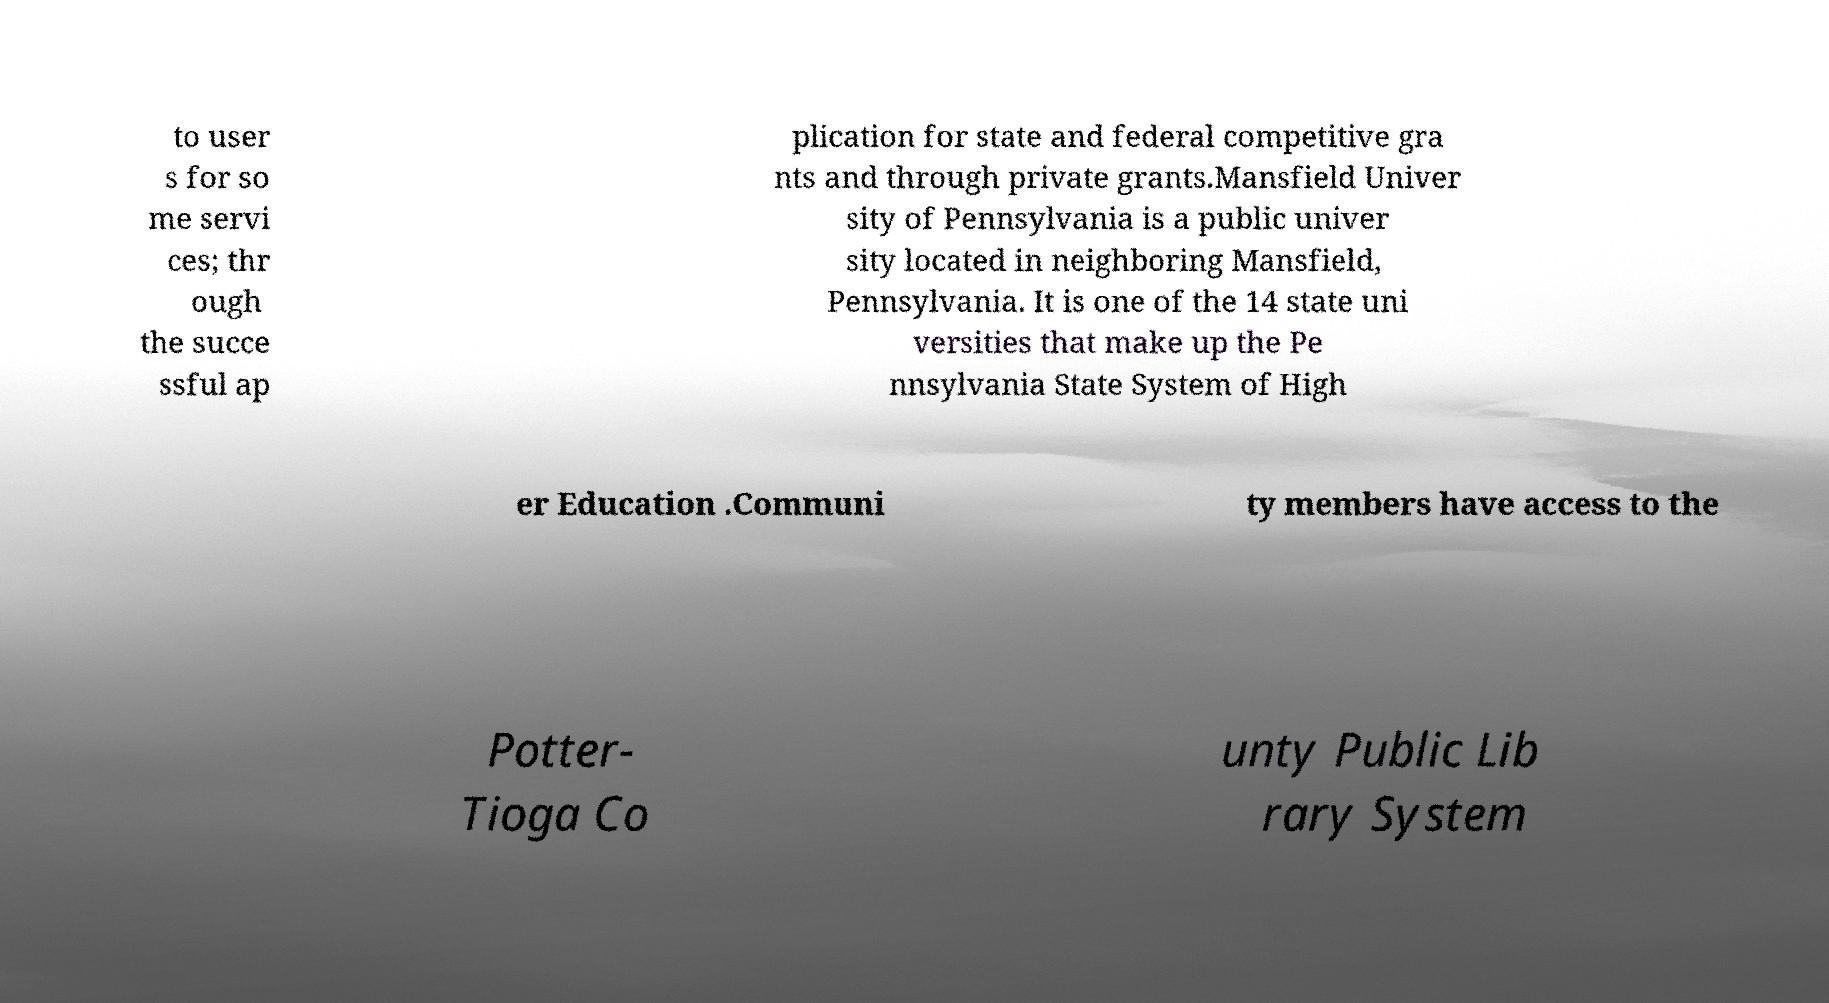For documentation purposes, I need the text within this image transcribed. Could you provide that? to user s for so me servi ces; thr ough the succe ssful ap plication for state and federal competitive gra nts and through private grants.Mansfield Univer sity of Pennsylvania is a public univer sity located in neighboring Mansfield, Pennsylvania. It is one of the 14 state uni versities that make up the Pe nnsylvania State System of High er Education .Communi ty members have access to the Potter- Tioga Co unty Public Lib rary System 